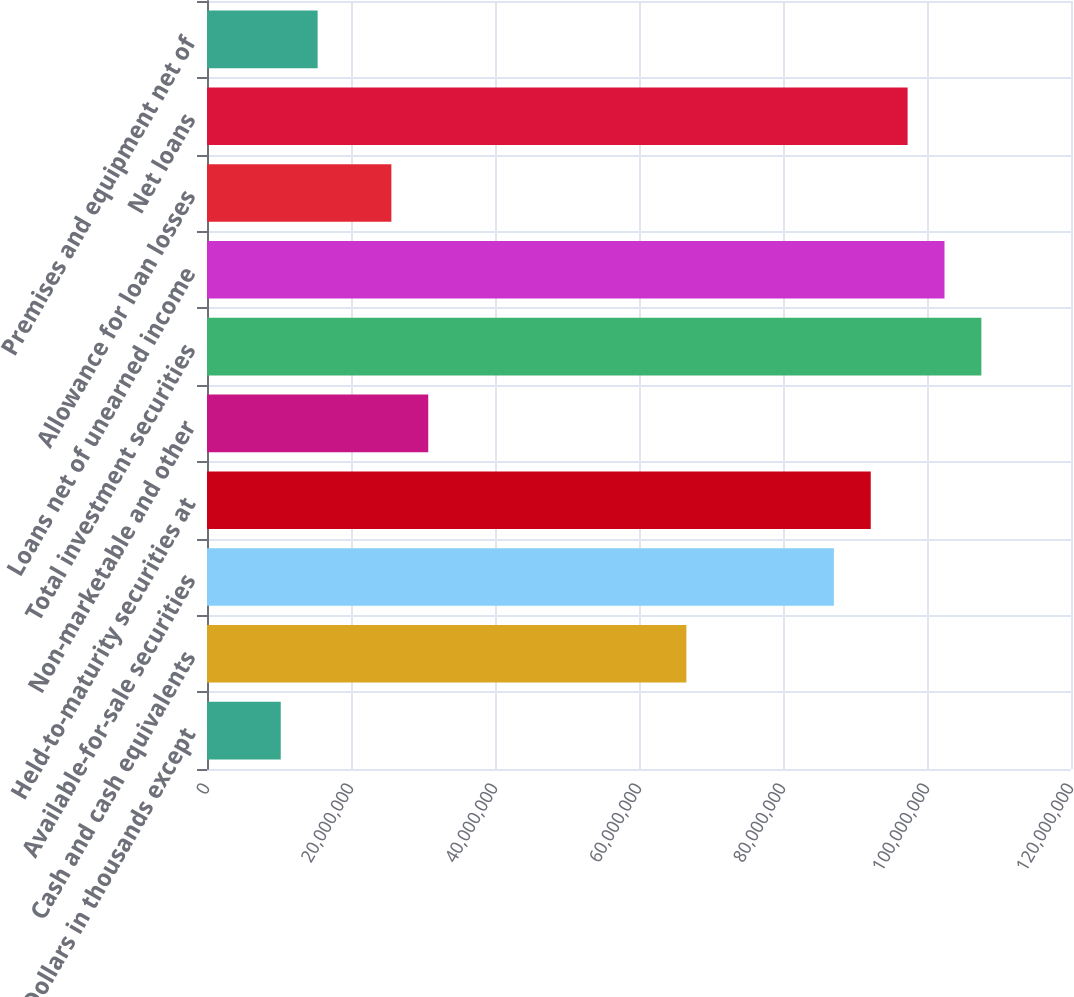Convert chart to OTSL. <chart><loc_0><loc_0><loc_500><loc_500><bar_chart><fcel>(Dollars in thousands except<fcel>Cash and cash equivalents<fcel>Available-for-sale securities<fcel>Held-to-maturity securities at<fcel>Non-marketable and other<fcel>Total investment securities<fcel>Loans net of unearned income<fcel>Allowance for loan losses<fcel>Net loans<fcel>Premises and equipment net of<nl><fcel>1.02429e+07<fcel>6.65788e+07<fcel>8.70646e+07<fcel>9.2186e+07<fcel>3.07287e+07<fcel>1.0755e+08<fcel>1.02429e+08<fcel>2.56073e+07<fcel>9.73074e+07<fcel>1.53644e+07<nl></chart> 